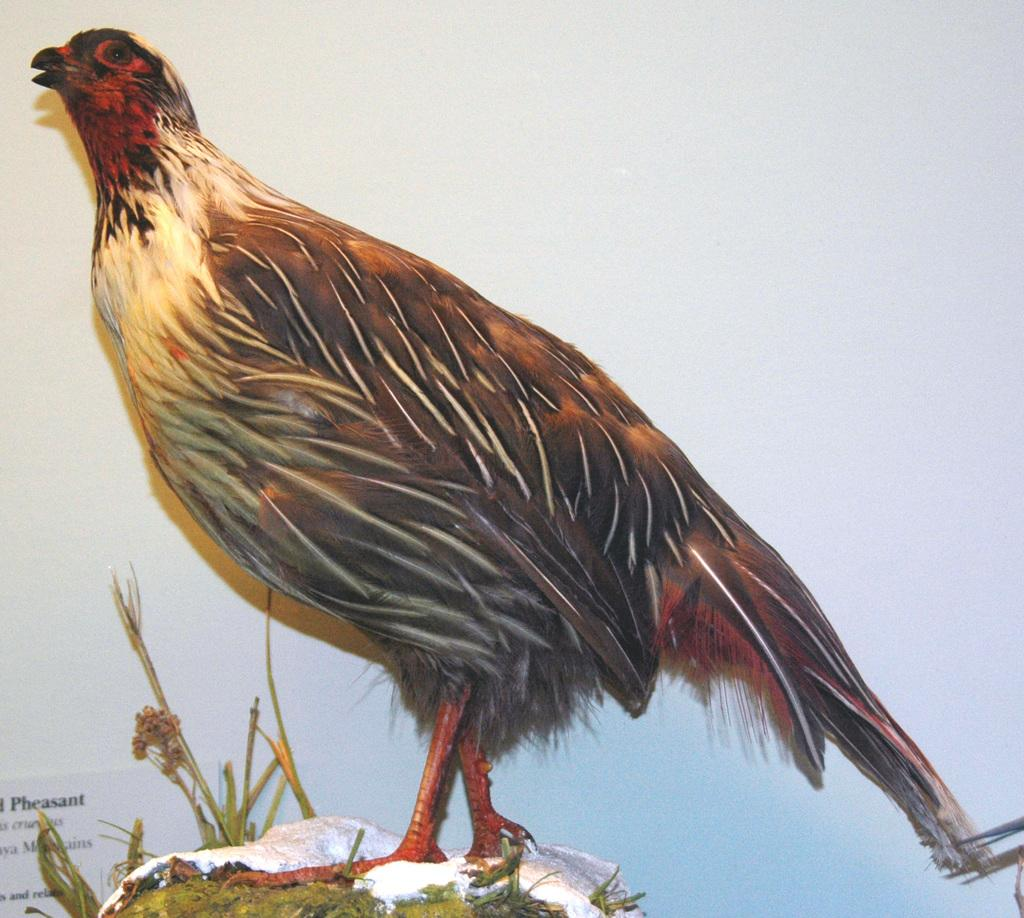What type of animal is in the image? There is a bird in the image. Can you describe the bird's appearance? The bird has gray, red, light brown, and white colors. What type of vegetation is present in the image? There are plants and grass in the image. Is there any text visible in the image? Yes, there is text in the image. How many rabbits can be seen balancing forks on their noses in the image? There are no rabbits or forks present in the image, so it is not possible to answer that question. 